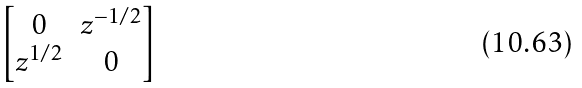Convert formula to latex. <formula><loc_0><loc_0><loc_500><loc_500>\begin{bmatrix} 0 & z ^ { - 1 / 2 } \\ z ^ { 1 / 2 } & 0 \end{bmatrix}</formula> 